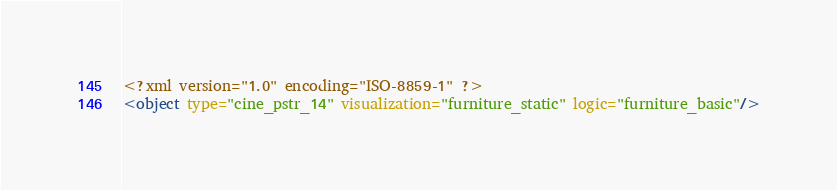<code> <loc_0><loc_0><loc_500><loc_500><_XML_><?xml version="1.0" encoding="ISO-8859-1" ?><object type="cine_pstr_14" visualization="furniture_static" logic="furniture_basic"/></code> 